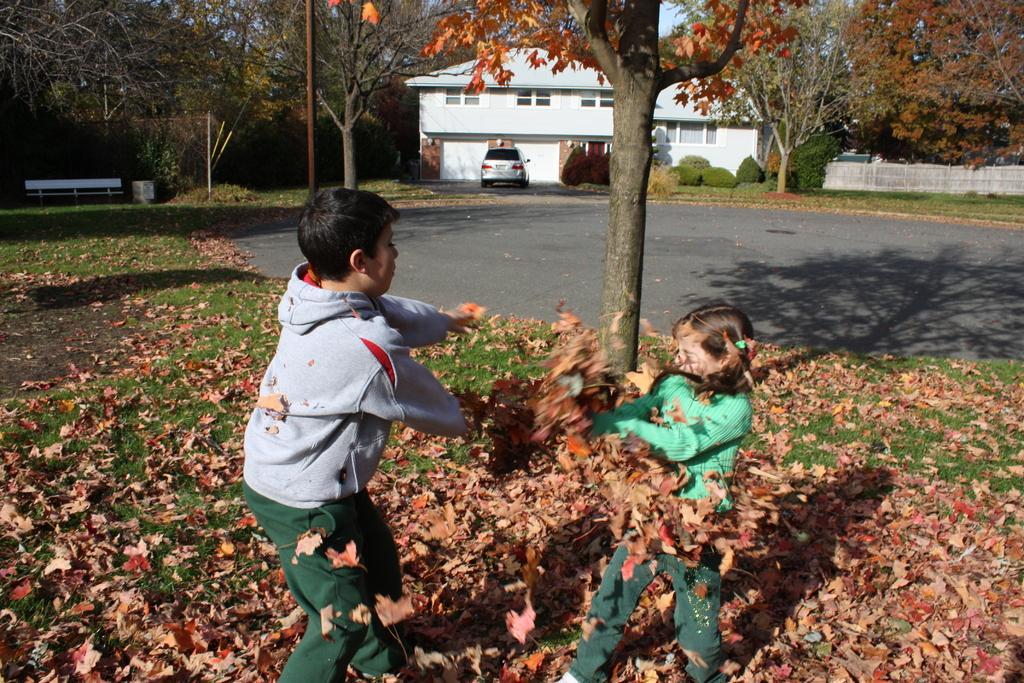Could you give a brief overview of what you see in this image? In this image I can see 2 children playing with dry leaves. There are trees, pole, a bench on the left. There is a building and a car at the back. 